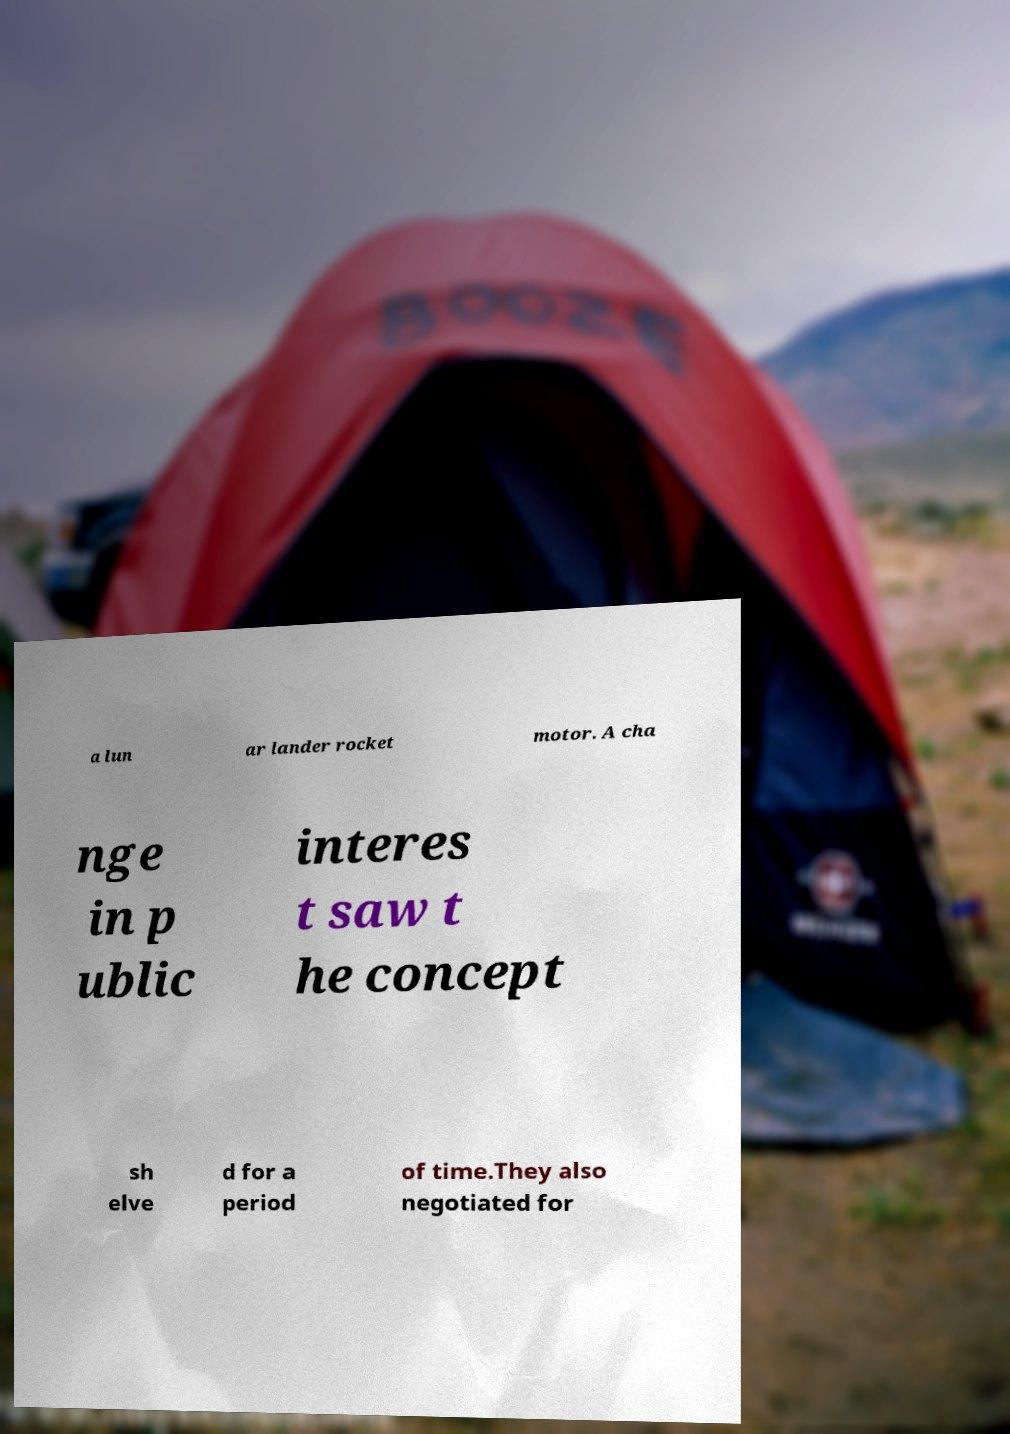Can you accurately transcribe the text from the provided image for me? a lun ar lander rocket motor. A cha nge in p ublic interes t saw t he concept sh elve d for a period of time.They also negotiated for 